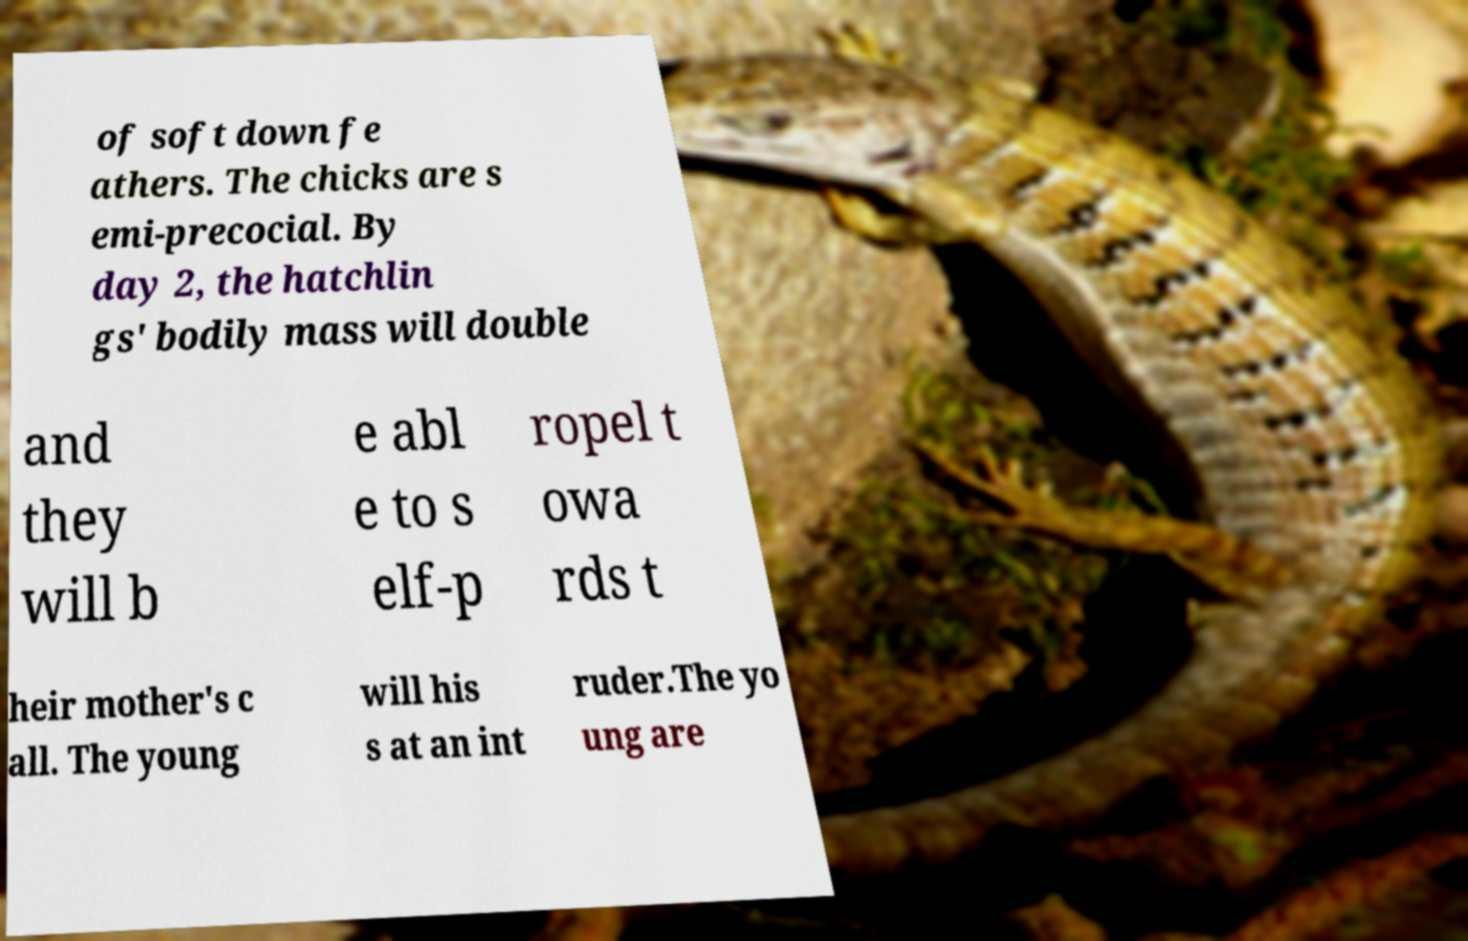Can you accurately transcribe the text from the provided image for me? of soft down fe athers. The chicks are s emi-precocial. By day 2, the hatchlin gs' bodily mass will double and they will b e abl e to s elf-p ropel t owa rds t heir mother's c all. The young will his s at an int ruder.The yo ung are 